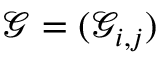<formula> <loc_0><loc_0><loc_500><loc_500>\mathcal { G } = ( \mathcal { G } _ { i , j } )</formula> 